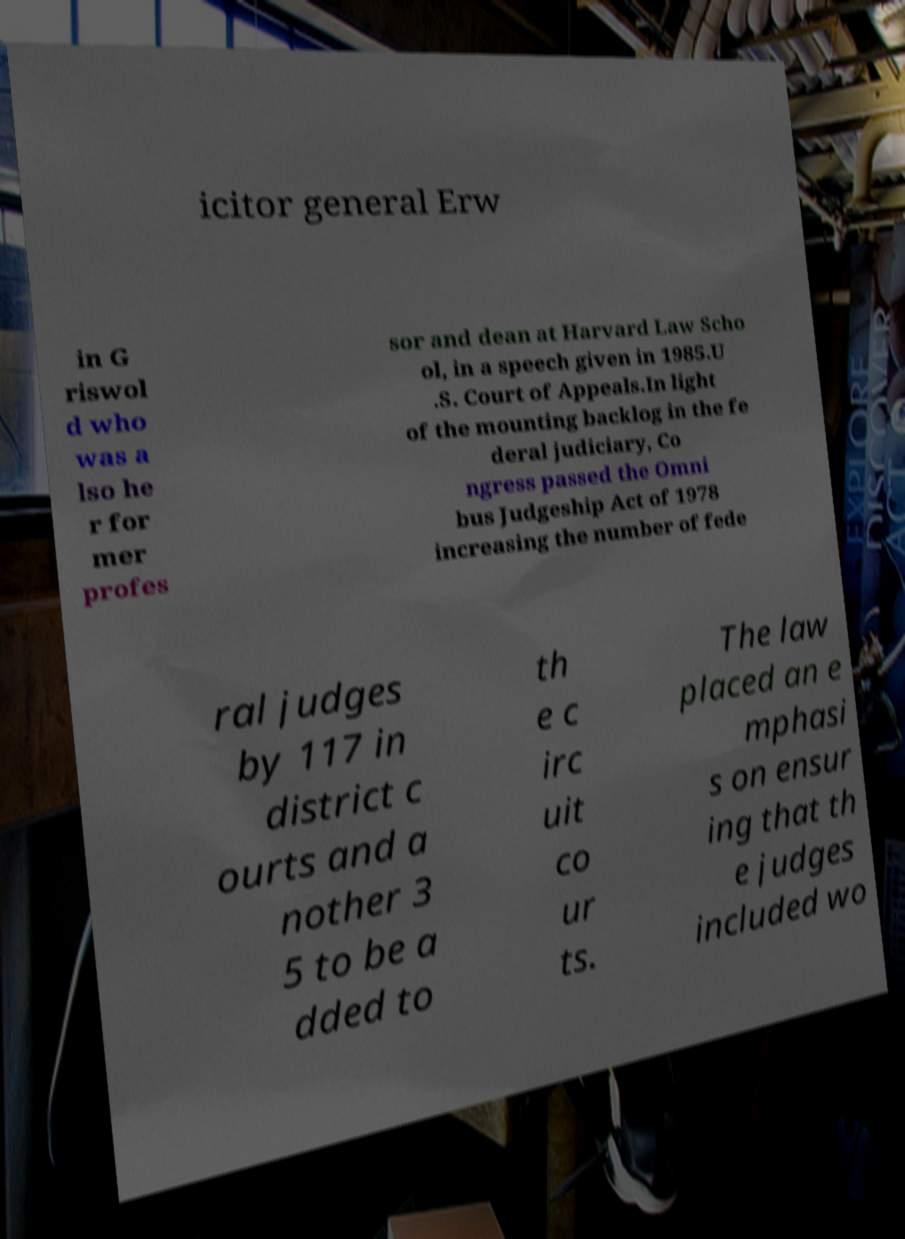For documentation purposes, I need the text within this image transcribed. Could you provide that? icitor general Erw in G riswol d who was a lso he r for mer profes sor and dean at Harvard Law Scho ol, in a speech given in 1985.U .S. Court of Appeals.In light of the mounting backlog in the fe deral judiciary, Co ngress passed the Omni bus Judgeship Act of 1978 increasing the number of fede ral judges by 117 in district c ourts and a nother 3 5 to be a dded to th e c irc uit co ur ts. The law placed an e mphasi s on ensur ing that th e judges included wo 